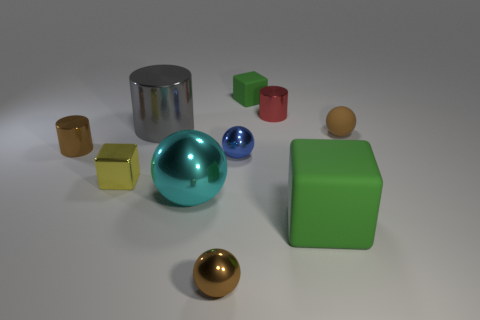There is a rubber object that is the same color as the small matte cube; what size is it?
Offer a terse response. Large. There is another big object that is the same shape as the brown matte object; what is it made of?
Make the answer very short. Metal. What number of gray matte cubes are the same size as the brown metal cylinder?
Offer a very short reply. 0. What color is the shiny thing that is right of the large cyan object and behind the small blue object?
Your answer should be compact. Red. Are there fewer big shiny cylinders than small shiny cylinders?
Your response must be concise. Yes. Does the big rubber block have the same color as the small cube that is right of the blue shiny sphere?
Your response must be concise. Yes. Are there the same number of small blue metal objects right of the tiny red shiny thing and small brown spheres behind the big cyan sphere?
Your answer should be very brief. No. How many brown things are the same shape as the gray metal thing?
Keep it short and to the point. 1. Are any big purple balls visible?
Your response must be concise. No. Are the tiny yellow thing and the cylinder that is in front of the large gray metal cylinder made of the same material?
Your answer should be compact. Yes. 